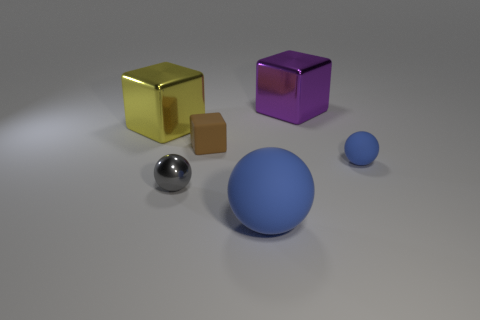What is the shape of the tiny rubber thing that is on the left side of the blue matte object on the right side of the big blue matte sphere?
Offer a terse response. Cube. What number of big things are gray metallic things or blue spheres?
Ensure brevity in your answer.  1. What number of brown objects have the same shape as the tiny blue thing?
Your answer should be very brief. 0. Is the shape of the small gray thing the same as the purple metal object right of the big rubber sphere?
Your response must be concise. No. What number of shiny objects are behind the rubber cube?
Your response must be concise. 2. Is there a cube of the same size as the gray shiny sphere?
Make the answer very short. Yes. There is a large thing that is to the right of the large matte thing; does it have the same shape as the large blue matte object?
Give a very brief answer. No. What color is the tiny rubber sphere?
Your answer should be compact. Blue. What is the shape of the tiny object that is the same color as the large matte ball?
Provide a succinct answer. Sphere. Are there any purple blocks?
Provide a succinct answer. Yes. 